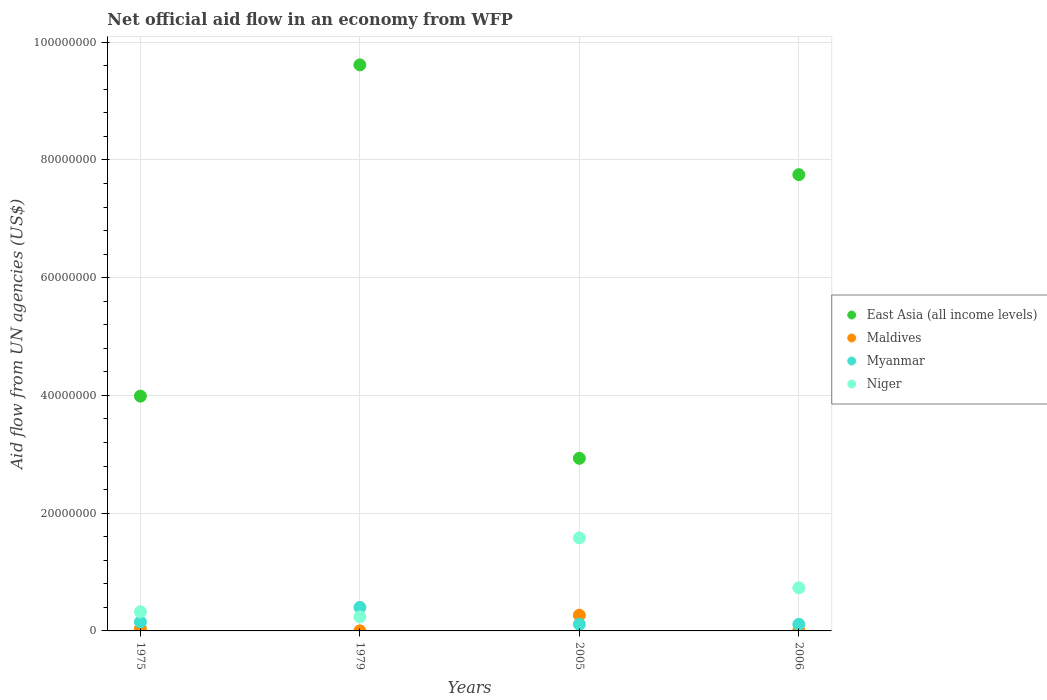How many different coloured dotlines are there?
Ensure brevity in your answer.  4. What is the net official aid flow in East Asia (all income levels) in 2005?
Your response must be concise. 2.93e+07. Across all years, what is the maximum net official aid flow in East Asia (all income levels)?
Give a very brief answer. 9.62e+07. Across all years, what is the minimum net official aid flow in Niger?
Give a very brief answer. 2.39e+06. In which year was the net official aid flow in Niger maximum?
Provide a succinct answer. 2005. In which year was the net official aid flow in Maldives minimum?
Ensure brevity in your answer.  1979. What is the total net official aid flow in Myanmar in the graph?
Keep it short and to the point. 7.77e+06. What is the difference between the net official aid flow in Myanmar in 1979 and that in 2006?
Your answer should be compact. 2.87e+06. What is the difference between the net official aid flow in Maldives in 2006 and the net official aid flow in East Asia (all income levels) in 1979?
Ensure brevity in your answer.  -9.61e+07. What is the average net official aid flow in Niger per year?
Your answer should be very brief. 7.19e+06. In the year 1975, what is the difference between the net official aid flow in Myanmar and net official aid flow in Niger?
Provide a short and direct response. -1.72e+06. In how many years, is the net official aid flow in East Asia (all income levels) greater than 20000000 US$?
Offer a terse response. 4. What is the ratio of the net official aid flow in East Asia (all income levels) in 1975 to that in 1979?
Ensure brevity in your answer.  0.41. Is the net official aid flow in East Asia (all income levels) in 1979 less than that in 2006?
Your response must be concise. No. What is the difference between the highest and the second highest net official aid flow in Niger?
Provide a succinct answer. 8.48e+06. What is the difference between the highest and the lowest net official aid flow in East Asia (all income levels)?
Offer a very short reply. 6.68e+07. In how many years, is the net official aid flow in East Asia (all income levels) greater than the average net official aid flow in East Asia (all income levels) taken over all years?
Give a very brief answer. 2. Is the sum of the net official aid flow in Myanmar in 1979 and 2006 greater than the maximum net official aid flow in Niger across all years?
Offer a terse response. No. Does the net official aid flow in Myanmar monotonically increase over the years?
Your response must be concise. No. Is the net official aid flow in Maldives strictly greater than the net official aid flow in Niger over the years?
Your response must be concise. No. How many dotlines are there?
Your answer should be compact. 4. How many years are there in the graph?
Provide a succinct answer. 4. What is the difference between two consecutive major ticks on the Y-axis?
Keep it short and to the point. 2.00e+07. Are the values on the major ticks of Y-axis written in scientific E-notation?
Your response must be concise. No. How are the legend labels stacked?
Provide a short and direct response. Vertical. What is the title of the graph?
Provide a succinct answer. Net official aid flow in an economy from WFP. What is the label or title of the X-axis?
Give a very brief answer. Years. What is the label or title of the Y-axis?
Offer a terse response. Aid flow from UN agencies (US$). What is the Aid flow from UN agencies (US$) of East Asia (all income levels) in 1975?
Your answer should be very brief. 3.99e+07. What is the Aid flow from UN agencies (US$) in Maldives in 1975?
Provide a succinct answer. 3.80e+05. What is the Aid flow from UN agencies (US$) of Myanmar in 1975?
Offer a very short reply. 1.53e+06. What is the Aid flow from UN agencies (US$) of Niger in 1975?
Make the answer very short. 3.25e+06. What is the Aid flow from UN agencies (US$) in East Asia (all income levels) in 1979?
Offer a terse response. 9.62e+07. What is the Aid flow from UN agencies (US$) of Maldives in 1979?
Offer a very short reply. 10000. What is the Aid flow from UN agencies (US$) of Myanmar in 1979?
Make the answer very short. 3.99e+06. What is the Aid flow from UN agencies (US$) in Niger in 1979?
Your response must be concise. 2.39e+06. What is the Aid flow from UN agencies (US$) in East Asia (all income levels) in 2005?
Make the answer very short. 2.93e+07. What is the Aid flow from UN agencies (US$) in Maldives in 2005?
Keep it short and to the point. 2.67e+06. What is the Aid flow from UN agencies (US$) of Myanmar in 2005?
Offer a very short reply. 1.13e+06. What is the Aid flow from UN agencies (US$) of Niger in 2005?
Ensure brevity in your answer.  1.58e+07. What is the Aid flow from UN agencies (US$) in East Asia (all income levels) in 2006?
Keep it short and to the point. 7.75e+07. What is the Aid flow from UN agencies (US$) of Maldives in 2006?
Your response must be concise. 8.00e+04. What is the Aid flow from UN agencies (US$) of Myanmar in 2006?
Provide a short and direct response. 1.12e+06. What is the Aid flow from UN agencies (US$) of Niger in 2006?
Give a very brief answer. 7.32e+06. Across all years, what is the maximum Aid flow from UN agencies (US$) of East Asia (all income levels)?
Your response must be concise. 9.62e+07. Across all years, what is the maximum Aid flow from UN agencies (US$) of Maldives?
Provide a succinct answer. 2.67e+06. Across all years, what is the maximum Aid flow from UN agencies (US$) of Myanmar?
Keep it short and to the point. 3.99e+06. Across all years, what is the maximum Aid flow from UN agencies (US$) in Niger?
Your response must be concise. 1.58e+07. Across all years, what is the minimum Aid flow from UN agencies (US$) in East Asia (all income levels)?
Offer a terse response. 2.93e+07. Across all years, what is the minimum Aid flow from UN agencies (US$) in Myanmar?
Provide a short and direct response. 1.12e+06. Across all years, what is the minimum Aid flow from UN agencies (US$) in Niger?
Provide a succinct answer. 2.39e+06. What is the total Aid flow from UN agencies (US$) of East Asia (all income levels) in the graph?
Provide a succinct answer. 2.43e+08. What is the total Aid flow from UN agencies (US$) of Maldives in the graph?
Your answer should be very brief. 3.14e+06. What is the total Aid flow from UN agencies (US$) of Myanmar in the graph?
Your answer should be very brief. 7.77e+06. What is the total Aid flow from UN agencies (US$) of Niger in the graph?
Make the answer very short. 2.88e+07. What is the difference between the Aid flow from UN agencies (US$) in East Asia (all income levels) in 1975 and that in 1979?
Your answer should be compact. -5.63e+07. What is the difference between the Aid flow from UN agencies (US$) in Maldives in 1975 and that in 1979?
Give a very brief answer. 3.70e+05. What is the difference between the Aid flow from UN agencies (US$) of Myanmar in 1975 and that in 1979?
Your answer should be very brief. -2.46e+06. What is the difference between the Aid flow from UN agencies (US$) in Niger in 1975 and that in 1979?
Your answer should be compact. 8.60e+05. What is the difference between the Aid flow from UN agencies (US$) in East Asia (all income levels) in 1975 and that in 2005?
Make the answer very short. 1.06e+07. What is the difference between the Aid flow from UN agencies (US$) in Maldives in 1975 and that in 2005?
Give a very brief answer. -2.29e+06. What is the difference between the Aid flow from UN agencies (US$) of Myanmar in 1975 and that in 2005?
Keep it short and to the point. 4.00e+05. What is the difference between the Aid flow from UN agencies (US$) of Niger in 1975 and that in 2005?
Provide a succinct answer. -1.26e+07. What is the difference between the Aid flow from UN agencies (US$) in East Asia (all income levels) in 1975 and that in 2006?
Give a very brief answer. -3.76e+07. What is the difference between the Aid flow from UN agencies (US$) of Maldives in 1975 and that in 2006?
Your answer should be compact. 3.00e+05. What is the difference between the Aid flow from UN agencies (US$) of Myanmar in 1975 and that in 2006?
Offer a terse response. 4.10e+05. What is the difference between the Aid flow from UN agencies (US$) in Niger in 1975 and that in 2006?
Make the answer very short. -4.07e+06. What is the difference between the Aid flow from UN agencies (US$) of East Asia (all income levels) in 1979 and that in 2005?
Provide a short and direct response. 6.68e+07. What is the difference between the Aid flow from UN agencies (US$) in Maldives in 1979 and that in 2005?
Provide a short and direct response. -2.66e+06. What is the difference between the Aid flow from UN agencies (US$) in Myanmar in 1979 and that in 2005?
Your answer should be compact. 2.86e+06. What is the difference between the Aid flow from UN agencies (US$) in Niger in 1979 and that in 2005?
Keep it short and to the point. -1.34e+07. What is the difference between the Aid flow from UN agencies (US$) of East Asia (all income levels) in 1979 and that in 2006?
Offer a very short reply. 1.86e+07. What is the difference between the Aid flow from UN agencies (US$) in Maldives in 1979 and that in 2006?
Offer a very short reply. -7.00e+04. What is the difference between the Aid flow from UN agencies (US$) in Myanmar in 1979 and that in 2006?
Offer a very short reply. 2.87e+06. What is the difference between the Aid flow from UN agencies (US$) in Niger in 1979 and that in 2006?
Your answer should be compact. -4.93e+06. What is the difference between the Aid flow from UN agencies (US$) in East Asia (all income levels) in 2005 and that in 2006?
Make the answer very short. -4.82e+07. What is the difference between the Aid flow from UN agencies (US$) in Maldives in 2005 and that in 2006?
Give a very brief answer. 2.59e+06. What is the difference between the Aid flow from UN agencies (US$) of Niger in 2005 and that in 2006?
Keep it short and to the point. 8.48e+06. What is the difference between the Aid flow from UN agencies (US$) of East Asia (all income levels) in 1975 and the Aid flow from UN agencies (US$) of Maldives in 1979?
Provide a short and direct response. 3.99e+07. What is the difference between the Aid flow from UN agencies (US$) in East Asia (all income levels) in 1975 and the Aid flow from UN agencies (US$) in Myanmar in 1979?
Your answer should be compact. 3.59e+07. What is the difference between the Aid flow from UN agencies (US$) of East Asia (all income levels) in 1975 and the Aid flow from UN agencies (US$) of Niger in 1979?
Provide a succinct answer. 3.75e+07. What is the difference between the Aid flow from UN agencies (US$) in Maldives in 1975 and the Aid flow from UN agencies (US$) in Myanmar in 1979?
Provide a short and direct response. -3.61e+06. What is the difference between the Aid flow from UN agencies (US$) in Maldives in 1975 and the Aid flow from UN agencies (US$) in Niger in 1979?
Offer a very short reply. -2.01e+06. What is the difference between the Aid flow from UN agencies (US$) of Myanmar in 1975 and the Aid flow from UN agencies (US$) of Niger in 1979?
Ensure brevity in your answer.  -8.60e+05. What is the difference between the Aid flow from UN agencies (US$) of East Asia (all income levels) in 1975 and the Aid flow from UN agencies (US$) of Maldives in 2005?
Give a very brief answer. 3.72e+07. What is the difference between the Aid flow from UN agencies (US$) in East Asia (all income levels) in 1975 and the Aid flow from UN agencies (US$) in Myanmar in 2005?
Your response must be concise. 3.88e+07. What is the difference between the Aid flow from UN agencies (US$) of East Asia (all income levels) in 1975 and the Aid flow from UN agencies (US$) of Niger in 2005?
Ensure brevity in your answer.  2.41e+07. What is the difference between the Aid flow from UN agencies (US$) in Maldives in 1975 and the Aid flow from UN agencies (US$) in Myanmar in 2005?
Your answer should be compact. -7.50e+05. What is the difference between the Aid flow from UN agencies (US$) in Maldives in 1975 and the Aid flow from UN agencies (US$) in Niger in 2005?
Provide a succinct answer. -1.54e+07. What is the difference between the Aid flow from UN agencies (US$) of Myanmar in 1975 and the Aid flow from UN agencies (US$) of Niger in 2005?
Provide a short and direct response. -1.43e+07. What is the difference between the Aid flow from UN agencies (US$) in East Asia (all income levels) in 1975 and the Aid flow from UN agencies (US$) in Maldives in 2006?
Offer a terse response. 3.98e+07. What is the difference between the Aid flow from UN agencies (US$) of East Asia (all income levels) in 1975 and the Aid flow from UN agencies (US$) of Myanmar in 2006?
Keep it short and to the point. 3.88e+07. What is the difference between the Aid flow from UN agencies (US$) of East Asia (all income levels) in 1975 and the Aid flow from UN agencies (US$) of Niger in 2006?
Provide a short and direct response. 3.26e+07. What is the difference between the Aid flow from UN agencies (US$) of Maldives in 1975 and the Aid flow from UN agencies (US$) of Myanmar in 2006?
Provide a succinct answer. -7.40e+05. What is the difference between the Aid flow from UN agencies (US$) of Maldives in 1975 and the Aid flow from UN agencies (US$) of Niger in 2006?
Keep it short and to the point. -6.94e+06. What is the difference between the Aid flow from UN agencies (US$) in Myanmar in 1975 and the Aid flow from UN agencies (US$) in Niger in 2006?
Offer a very short reply. -5.79e+06. What is the difference between the Aid flow from UN agencies (US$) in East Asia (all income levels) in 1979 and the Aid flow from UN agencies (US$) in Maldives in 2005?
Your response must be concise. 9.35e+07. What is the difference between the Aid flow from UN agencies (US$) in East Asia (all income levels) in 1979 and the Aid flow from UN agencies (US$) in Myanmar in 2005?
Your answer should be very brief. 9.50e+07. What is the difference between the Aid flow from UN agencies (US$) in East Asia (all income levels) in 1979 and the Aid flow from UN agencies (US$) in Niger in 2005?
Ensure brevity in your answer.  8.04e+07. What is the difference between the Aid flow from UN agencies (US$) of Maldives in 1979 and the Aid flow from UN agencies (US$) of Myanmar in 2005?
Provide a short and direct response. -1.12e+06. What is the difference between the Aid flow from UN agencies (US$) in Maldives in 1979 and the Aid flow from UN agencies (US$) in Niger in 2005?
Give a very brief answer. -1.58e+07. What is the difference between the Aid flow from UN agencies (US$) of Myanmar in 1979 and the Aid flow from UN agencies (US$) of Niger in 2005?
Provide a succinct answer. -1.18e+07. What is the difference between the Aid flow from UN agencies (US$) of East Asia (all income levels) in 1979 and the Aid flow from UN agencies (US$) of Maldives in 2006?
Keep it short and to the point. 9.61e+07. What is the difference between the Aid flow from UN agencies (US$) in East Asia (all income levels) in 1979 and the Aid flow from UN agencies (US$) in Myanmar in 2006?
Your answer should be very brief. 9.50e+07. What is the difference between the Aid flow from UN agencies (US$) of East Asia (all income levels) in 1979 and the Aid flow from UN agencies (US$) of Niger in 2006?
Your response must be concise. 8.88e+07. What is the difference between the Aid flow from UN agencies (US$) of Maldives in 1979 and the Aid flow from UN agencies (US$) of Myanmar in 2006?
Offer a very short reply. -1.11e+06. What is the difference between the Aid flow from UN agencies (US$) of Maldives in 1979 and the Aid flow from UN agencies (US$) of Niger in 2006?
Your answer should be very brief. -7.31e+06. What is the difference between the Aid flow from UN agencies (US$) in Myanmar in 1979 and the Aid flow from UN agencies (US$) in Niger in 2006?
Keep it short and to the point. -3.33e+06. What is the difference between the Aid flow from UN agencies (US$) in East Asia (all income levels) in 2005 and the Aid flow from UN agencies (US$) in Maldives in 2006?
Your answer should be compact. 2.92e+07. What is the difference between the Aid flow from UN agencies (US$) of East Asia (all income levels) in 2005 and the Aid flow from UN agencies (US$) of Myanmar in 2006?
Provide a short and direct response. 2.82e+07. What is the difference between the Aid flow from UN agencies (US$) in East Asia (all income levels) in 2005 and the Aid flow from UN agencies (US$) in Niger in 2006?
Keep it short and to the point. 2.20e+07. What is the difference between the Aid flow from UN agencies (US$) in Maldives in 2005 and the Aid flow from UN agencies (US$) in Myanmar in 2006?
Ensure brevity in your answer.  1.55e+06. What is the difference between the Aid flow from UN agencies (US$) in Maldives in 2005 and the Aid flow from UN agencies (US$) in Niger in 2006?
Provide a succinct answer. -4.65e+06. What is the difference between the Aid flow from UN agencies (US$) in Myanmar in 2005 and the Aid flow from UN agencies (US$) in Niger in 2006?
Keep it short and to the point. -6.19e+06. What is the average Aid flow from UN agencies (US$) of East Asia (all income levels) per year?
Provide a short and direct response. 6.07e+07. What is the average Aid flow from UN agencies (US$) of Maldives per year?
Provide a succinct answer. 7.85e+05. What is the average Aid flow from UN agencies (US$) in Myanmar per year?
Keep it short and to the point. 1.94e+06. What is the average Aid flow from UN agencies (US$) in Niger per year?
Provide a short and direct response. 7.19e+06. In the year 1975, what is the difference between the Aid flow from UN agencies (US$) of East Asia (all income levels) and Aid flow from UN agencies (US$) of Maldives?
Your answer should be very brief. 3.95e+07. In the year 1975, what is the difference between the Aid flow from UN agencies (US$) of East Asia (all income levels) and Aid flow from UN agencies (US$) of Myanmar?
Give a very brief answer. 3.84e+07. In the year 1975, what is the difference between the Aid flow from UN agencies (US$) in East Asia (all income levels) and Aid flow from UN agencies (US$) in Niger?
Give a very brief answer. 3.66e+07. In the year 1975, what is the difference between the Aid flow from UN agencies (US$) of Maldives and Aid flow from UN agencies (US$) of Myanmar?
Ensure brevity in your answer.  -1.15e+06. In the year 1975, what is the difference between the Aid flow from UN agencies (US$) of Maldives and Aid flow from UN agencies (US$) of Niger?
Offer a terse response. -2.87e+06. In the year 1975, what is the difference between the Aid flow from UN agencies (US$) in Myanmar and Aid flow from UN agencies (US$) in Niger?
Your answer should be very brief. -1.72e+06. In the year 1979, what is the difference between the Aid flow from UN agencies (US$) of East Asia (all income levels) and Aid flow from UN agencies (US$) of Maldives?
Offer a very short reply. 9.61e+07. In the year 1979, what is the difference between the Aid flow from UN agencies (US$) in East Asia (all income levels) and Aid flow from UN agencies (US$) in Myanmar?
Make the answer very short. 9.22e+07. In the year 1979, what is the difference between the Aid flow from UN agencies (US$) in East Asia (all income levels) and Aid flow from UN agencies (US$) in Niger?
Your answer should be compact. 9.38e+07. In the year 1979, what is the difference between the Aid flow from UN agencies (US$) in Maldives and Aid flow from UN agencies (US$) in Myanmar?
Keep it short and to the point. -3.98e+06. In the year 1979, what is the difference between the Aid flow from UN agencies (US$) in Maldives and Aid flow from UN agencies (US$) in Niger?
Your answer should be compact. -2.38e+06. In the year 1979, what is the difference between the Aid flow from UN agencies (US$) in Myanmar and Aid flow from UN agencies (US$) in Niger?
Give a very brief answer. 1.60e+06. In the year 2005, what is the difference between the Aid flow from UN agencies (US$) of East Asia (all income levels) and Aid flow from UN agencies (US$) of Maldives?
Your response must be concise. 2.66e+07. In the year 2005, what is the difference between the Aid flow from UN agencies (US$) in East Asia (all income levels) and Aid flow from UN agencies (US$) in Myanmar?
Keep it short and to the point. 2.82e+07. In the year 2005, what is the difference between the Aid flow from UN agencies (US$) of East Asia (all income levels) and Aid flow from UN agencies (US$) of Niger?
Make the answer very short. 1.35e+07. In the year 2005, what is the difference between the Aid flow from UN agencies (US$) of Maldives and Aid flow from UN agencies (US$) of Myanmar?
Your answer should be very brief. 1.54e+06. In the year 2005, what is the difference between the Aid flow from UN agencies (US$) in Maldives and Aid flow from UN agencies (US$) in Niger?
Provide a short and direct response. -1.31e+07. In the year 2005, what is the difference between the Aid flow from UN agencies (US$) in Myanmar and Aid flow from UN agencies (US$) in Niger?
Your answer should be very brief. -1.47e+07. In the year 2006, what is the difference between the Aid flow from UN agencies (US$) in East Asia (all income levels) and Aid flow from UN agencies (US$) in Maldives?
Give a very brief answer. 7.74e+07. In the year 2006, what is the difference between the Aid flow from UN agencies (US$) of East Asia (all income levels) and Aid flow from UN agencies (US$) of Myanmar?
Keep it short and to the point. 7.64e+07. In the year 2006, what is the difference between the Aid flow from UN agencies (US$) of East Asia (all income levels) and Aid flow from UN agencies (US$) of Niger?
Keep it short and to the point. 7.02e+07. In the year 2006, what is the difference between the Aid flow from UN agencies (US$) of Maldives and Aid flow from UN agencies (US$) of Myanmar?
Offer a terse response. -1.04e+06. In the year 2006, what is the difference between the Aid flow from UN agencies (US$) of Maldives and Aid flow from UN agencies (US$) of Niger?
Your answer should be compact. -7.24e+06. In the year 2006, what is the difference between the Aid flow from UN agencies (US$) of Myanmar and Aid flow from UN agencies (US$) of Niger?
Offer a terse response. -6.20e+06. What is the ratio of the Aid flow from UN agencies (US$) of East Asia (all income levels) in 1975 to that in 1979?
Make the answer very short. 0.41. What is the ratio of the Aid flow from UN agencies (US$) in Maldives in 1975 to that in 1979?
Keep it short and to the point. 38. What is the ratio of the Aid flow from UN agencies (US$) of Myanmar in 1975 to that in 1979?
Provide a succinct answer. 0.38. What is the ratio of the Aid flow from UN agencies (US$) of Niger in 1975 to that in 1979?
Offer a very short reply. 1.36. What is the ratio of the Aid flow from UN agencies (US$) in East Asia (all income levels) in 1975 to that in 2005?
Ensure brevity in your answer.  1.36. What is the ratio of the Aid flow from UN agencies (US$) in Maldives in 1975 to that in 2005?
Give a very brief answer. 0.14. What is the ratio of the Aid flow from UN agencies (US$) of Myanmar in 1975 to that in 2005?
Your response must be concise. 1.35. What is the ratio of the Aid flow from UN agencies (US$) in Niger in 1975 to that in 2005?
Your response must be concise. 0.21. What is the ratio of the Aid flow from UN agencies (US$) of East Asia (all income levels) in 1975 to that in 2006?
Provide a succinct answer. 0.51. What is the ratio of the Aid flow from UN agencies (US$) of Maldives in 1975 to that in 2006?
Keep it short and to the point. 4.75. What is the ratio of the Aid flow from UN agencies (US$) of Myanmar in 1975 to that in 2006?
Give a very brief answer. 1.37. What is the ratio of the Aid flow from UN agencies (US$) of Niger in 1975 to that in 2006?
Give a very brief answer. 0.44. What is the ratio of the Aid flow from UN agencies (US$) of East Asia (all income levels) in 1979 to that in 2005?
Ensure brevity in your answer.  3.28. What is the ratio of the Aid flow from UN agencies (US$) in Maldives in 1979 to that in 2005?
Give a very brief answer. 0. What is the ratio of the Aid flow from UN agencies (US$) of Myanmar in 1979 to that in 2005?
Offer a very short reply. 3.53. What is the ratio of the Aid flow from UN agencies (US$) of Niger in 1979 to that in 2005?
Provide a succinct answer. 0.15. What is the ratio of the Aid flow from UN agencies (US$) in East Asia (all income levels) in 1979 to that in 2006?
Offer a terse response. 1.24. What is the ratio of the Aid flow from UN agencies (US$) in Maldives in 1979 to that in 2006?
Keep it short and to the point. 0.12. What is the ratio of the Aid flow from UN agencies (US$) of Myanmar in 1979 to that in 2006?
Keep it short and to the point. 3.56. What is the ratio of the Aid flow from UN agencies (US$) of Niger in 1979 to that in 2006?
Offer a terse response. 0.33. What is the ratio of the Aid flow from UN agencies (US$) of East Asia (all income levels) in 2005 to that in 2006?
Ensure brevity in your answer.  0.38. What is the ratio of the Aid flow from UN agencies (US$) in Maldives in 2005 to that in 2006?
Keep it short and to the point. 33.38. What is the ratio of the Aid flow from UN agencies (US$) in Myanmar in 2005 to that in 2006?
Your answer should be compact. 1.01. What is the ratio of the Aid flow from UN agencies (US$) of Niger in 2005 to that in 2006?
Make the answer very short. 2.16. What is the difference between the highest and the second highest Aid flow from UN agencies (US$) in East Asia (all income levels)?
Ensure brevity in your answer.  1.86e+07. What is the difference between the highest and the second highest Aid flow from UN agencies (US$) in Maldives?
Offer a very short reply. 2.29e+06. What is the difference between the highest and the second highest Aid flow from UN agencies (US$) in Myanmar?
Give a very brief answer. 2.46e+06. What is the difference between the highest and the second highest Aid flow from UN agencies (US$) in Niger?
Make the answer very short. 8.48e+06. What is the difference between the highest and the lowest Aid flow from UN agencies (US$) in East Asia (all income levels)?
Provide a succinct answer. 6.68e+07. What is the difference between the highest and the lowest Aid flow from UN agencies (US$) of Maldives?
Your answer should be very brief. 2.66e+06. What is the difference between the highest and the lowest Aid flow from UN agencies (US$) of Myanmar?
Your answer should be very brief. 2.87e+06. What is the difference between the highest and the lowest Aid flow from UN agencies (US$) of Niger?
Offer a very short reply. 1.34e+07. 